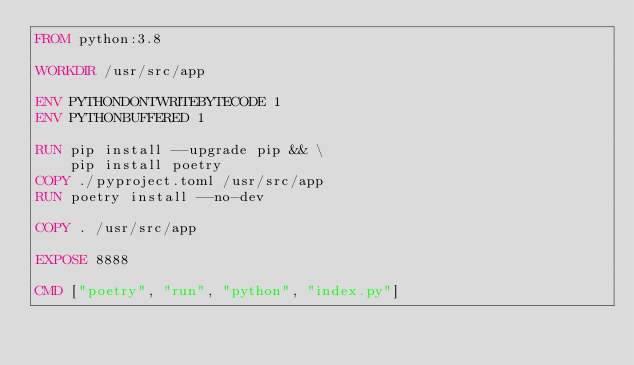Convert code to text. <code><loc_0><loc_0><loc_500><loc_500><_Dockerfile_>FROM python:3.8

WORKDIR /usr/src/app

ENV PYTHONDONTWRITEBYTECODE 1
ENV PYTHONBUFFERED 1

RUN pip install --upgrade pip && \
    pip install poetry
COPY ./pyproject.toml /usr/src/app
RUN poetry install --no-dev

COPY . /usr/src/app

EXPOSE 8888

CMD ["poetry", "run", "python", "index.py"]
</code> 